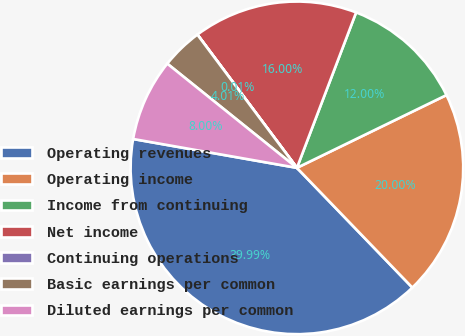Convert chart to OTSL. <chart><loc_0><loc_0><loc_500><loc_500><pie_chart><fcel>Operating revenues<fcel>Operating income<fcel>Income from continuing<fcel>Net income<fcel>Continuing operations<fcel>Basic earnings per common<fcel>Diluted earnings per common<nl><fcel>39.99%<fcel>20.0%<fcel>12.0%<fcel>16.0%<fcel>0.01%<fcel>4.01%<fcel>8.0%<nl></chart> 